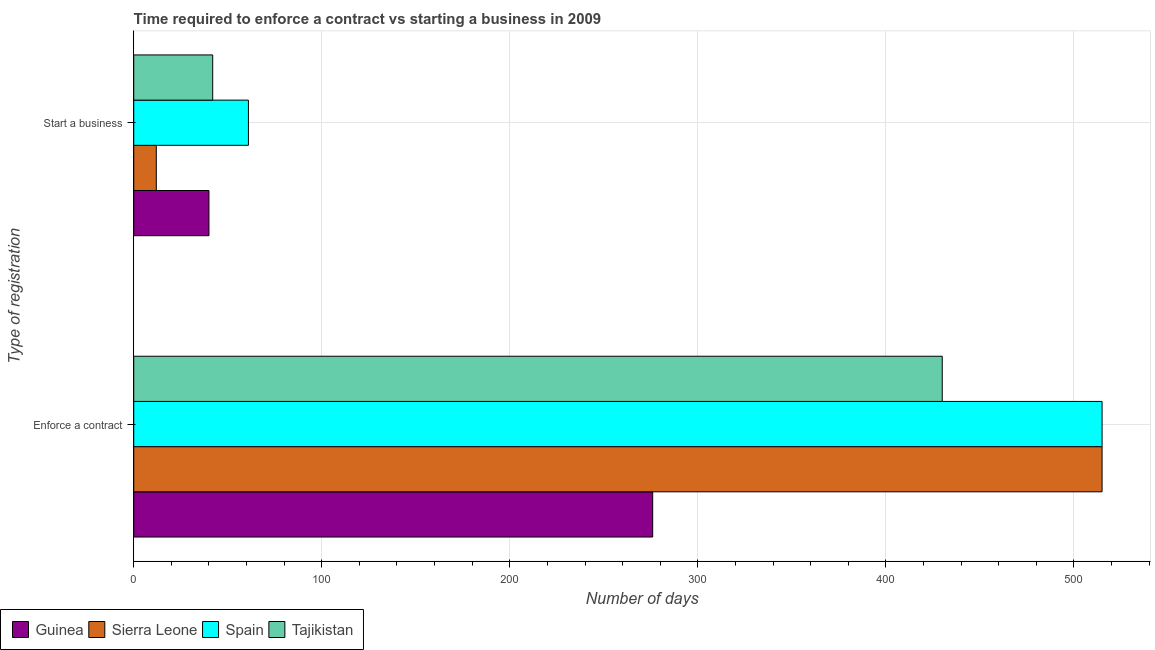How many groups of bars are there?
Provide a short and direct response. 2. Are the number of bars per tick equal to the number of legend labels?
Your response must be concise. Yes. What is the label of the 2nd group of bars from the top?
Give a very brief answer. Enforce a contract. What is the number of days to start a business in Sierra Leone?
Offer a very short reply. 12. Across all countries, what is the maximum number of days to start a business?
Give a very brief answer. 61. Across all countries, what is the minimum number of days to start a business?
Your answer should be compact. 12. In which country was the number of days to enforece a contract maximum?
Your response must be concise. Sierra Leone. In which country was the number of days to enforece a contract minimum?
Provide a succinct answer. Guinea. What is the total number of days to enforece a contract in the graph?
Offer a terse response. 1736. What is the difference between the number of days to start a business in Guinea and that in Tajikistan?
Your response must be concise. -2. What is the difference between the number of days to start a business in Tajikistan and the number of days to enforece a contract in Sierra Leone?
Offer a terse response. -473. What is the average number of days to enforece a contract per country?
Ensure brevity in your answer.  434. What is the difference between the number of days to enforece a contract and number of days to start a business in Spain?
Offer a very short reply. 454. What is the ratio of the number of days to start a business in Tajikistan to that in Guinea?
Provide a succinct answer. 1.05. What does the 3rd bar from the top in Start a business represents?
Provide a short and direct response. Sierra Leone. What does the 3rd bar from the bottom in Enforce a contract represents?
Your response must be concise. Spain. How many bars are there?
Offer a very short reply. 8. Are all the bars in the graph horizontal?
Offer a terse response. Yes. How many countries are there in the graph?
Provide a succinct answer. 4. Does the graph contain any zero values?
Your answer should be compact. No. Where does the legend appear in the graph?
Provide a short and direct response. Bottom left. How many legend labels are there?
Your answer should be compact. 4. How are the legend labels stacked?
Your response must be concise. Horizontal. What is the title of the graph?
Make the answer very short. Time required to enforce a contract vs starting a business in 2009. Does "Least developed countries" appear as one of the legend labels in the graph?
Ensure brevity in your answer.  No. What is the label or title of the X-axis?
Provide a short and direct response. Number of days. What is the label or title of the Y-axis?
Offer a very short reply. Type of registration. What is the Number of days of Guinea in Enforce a contract?
Offer a terse response. 276. What is the Number of days in Sierra Leone in Enforce a contract?
Give a very brief answer. 515. What is the Number of days in Spain in Enforce a contract?
Your answer should be compact. 515. What is the Number of days of Tajikistan in Enforce a contract?
Give a very brief answer. 430. What is the Number of days in Spain in Start a business?
Make the answer very short. 61. What is the Number of days of Tajikistan in Start a business?
Keep it short and to the point. 42. Across all Type of registration, what is the maximum Number of days of Guinea?
Keep it short and to the point. 276. Across all Type of registration, what is the maximum Number of days in Sierra Leone?
Make the answer very short. 515. Across all Type of registration, what is the maximum Number of days of Spain?
Keep it short and to the point. 515. Across all Type of registration, what is the maximum Number of days in Tajikistan?
Your answer should be very brief. 430. Across all Type of registration, what is the minimum Number of days in Sierra Leone?
Offer a terse response. 12. Across all Type of registration, what is the minimum Number of days in Spain?
Provide a short and direct response. 61. Across all Type of registration, what is the minimum Number of days of Tajikistan?
Provide a short and direct response. 42. What is the total Number of days of Guinea in the graph?
Provide a short and direct response. 316. What is the total Number of days of Sierra Leone in the graph?
Give a very brief answer. 527. What is the total Number of days in Spain in the graph?
Your response must be concise. 576. What is the total Number of days in Tajikistan in the graph?
Ensure brevity in your answer.  472. What is the difference between the Number of days in Guinea in Enforce a contract and that in Start a business?
Offer a very short reply. 236. What is the difference between the Number of days in Sierra Leone in Enforce a contract and that in Start a business?
Offer a terse response. 503. What is the difference between the Number of days in Spain in Enforce a contract and that in Start a business?
Keep it short and to the point. 454. What is the difference between the Number of days in Tajikistan in Enforce a contract and that in Start a business?
Provide a succinct answer. 388. What is the difference between the Number of days in Guinea in Enforce a contract and the Number of days in Sierra Leone in Start a business?
Offer a terse response. 264. What is the difference between the Number of days of Guinea in Enforce a contract and the Number of days of Spain in Start a business?
Offer a terse response. 215. What is the difference between the Number of days in Guinea in Enforce a contract and the Number of days in Tajikistan in Start a business?
Offer a terse response. 234. What is the difference between the Number of days in Sierra Leone in Enforce a contract and the Number of days in Spain in Start a business?
Your answer should be very brief. 454. What is the difference between the Number of days in Sierra Leone in Enforce a contract and the Number of days in Tajikistan in Start a business?
Provide a succinct answer. 473. What is the difference between the Number of days in Spain in Enforce a contract and the Number of days in Tajikistan in Start a business?
Ensure brevity in your answer.  473. What is the average Number of days of Guinea per Type of registration?
Your answer should be very brief. 158. What is the average Number of days in Sierra Leone per Type of registration?
Your answer should be compact. 263.5. What is the average Number of days of Spain per Type of registration?
Your response must be concise. 288. What is the average Number of days of Tajikistan per Type of registration?
Keep it short and to the point. 236. What is the difference between the Number of days of Guinea and Number of days of Sierra Leone in Enforce a contract?
Your answer should be compact. -239. What is the difference between the Number of days in Guinea and Number of days in Spain in Enforce a contract?
Ensure brevity in your answer.  -239. What is the difference between the Number of days in Guinea and Number of days in Tajikistan in Enforce a contract?
Provide a succinct answer. -154. What is the difference between the Number of days in Sierra Leone and Number of days in Spain in Enforce a contract?
Make the answer very short. 0. What is the difference between the Number of days of Spain and Number of days of Tajikistan in Enforce a contract?
Provide a succinct answer. 85. What is the difference between the Number of days in Guinea and Number of days in Spain in Start a business?
Your answer should be very brief. -21. What is the difference between the Number of days in Guinea and Number of days in Tajikistan in Start a business?
Provide a short and direct response. -2. What is the difference between the Number of days of Sierra Leone and Number of days of Spain in Start a business?
Provide a succinct answer. -49. What is the difference between the Number of days of Spain and Number of days of Tajikistan in Start a business?
Your answer should be compact. 19. What is the ratio of the Number of days of Sierra Leone in Enforce a contract to that in Start a business?
Provide a succinct answer. 42.92. What is the ratio of the Number of days of Spain in Enforce a contract to that in Start a business?
Provide a short and direct response. 8.44. What is the ratio of the Number of days in Tajikistan in Enforce a contract to that in Start a business?
Give a very brief answer. 10.24. What is the difference between the highest and the second highest Number of days of Guinea?
Your answer should be compact. 236. What is the difference between the highest and the second highest Number of days in Sierra Leone?
Your answer should be very brief. 503. What is the difference between the highest and the second highest Number of days of Spain?
Make the answer very short. 454. What is the difference between the highest and the second highest Number of days in Tajikistan?
Offer a terse response. 388. What is the difference between the highest and the lowest Number of days of Guinea?
Provide a short and direct response. 236. What is the difference between the highest and the lowest Number of days of Sierra Leone?
Provide a succinct answer. 503. What is the difference between the highest and the lowest Number of days in Spain?
Your answer should be very brief. 454. What is the difference between the highest and the lowest Number of days in Tajikistan?
Your answer should be compact. 388. 